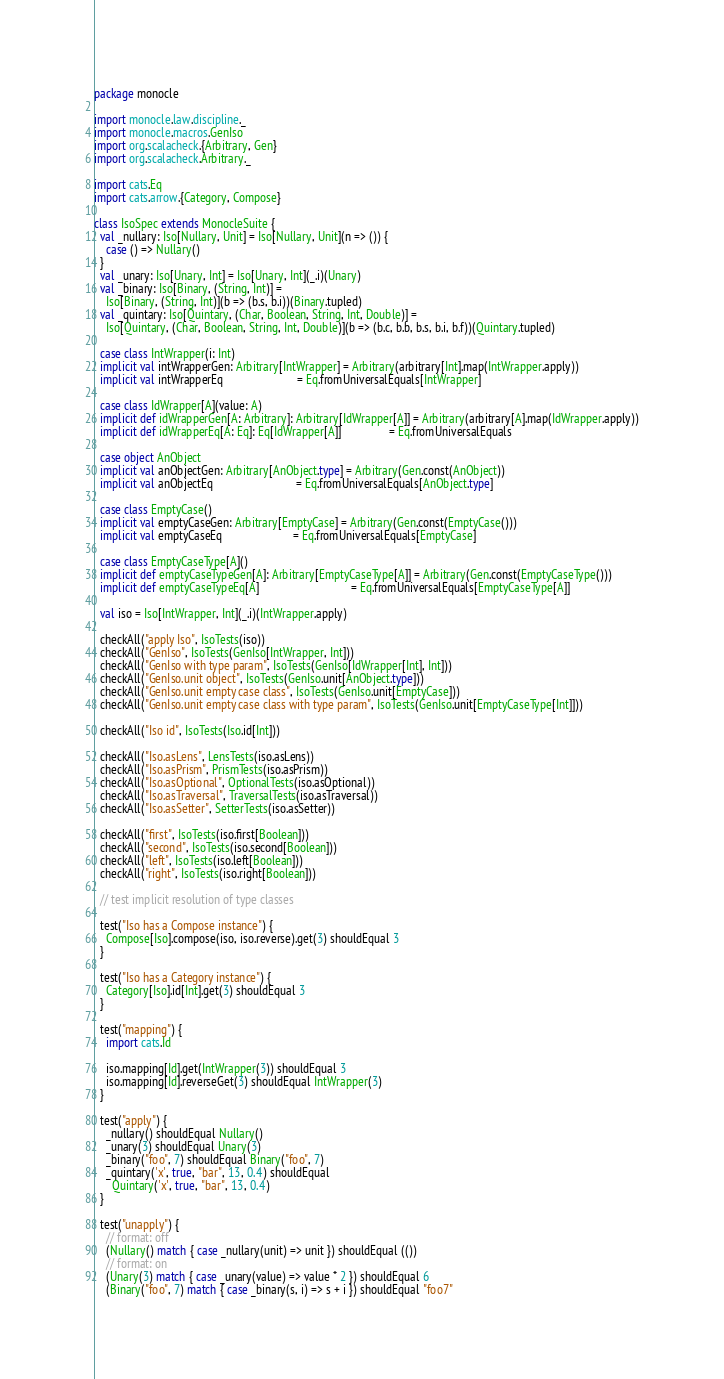Convert code to text. <code><loc_0><loc_0><loc_500><loc_500><_Scala_>package monocle

import monocle.law.discipline._
import monocle.macros.GenIso
import org.scalacheck.{Arbitrary, Gen}
import org.scalacheck.Arbitrary._

import cats.Eq
import cats.arrow.{Category, Compose}

class IsoSpec extends MonocleSuite {
  val _nullary: Iso[Nullary, Unit] = Iso[Nullary, Unit](n => ()) {
    case () => Nullary()
  }
  val _unary: Iso[Unary, Int] = Iso[Unary, Int](_.i)(Unary)
  val _binary: Iso[Binary, (String, Int)] =
    Iso[Binary, (String, Int)](b => (b.s, b.i))(Binary.tupled)
  val _quintary: Iso[Quintary, (Char, Boolean, String, Int, Double)] =
    Iso[Quintary, (Char, Boolean, String, Int, Double)](b => (b.c, b.b, b.s, b.i, b.f))(Quintary.tupled)

  case class IntWrapper(i: Int)
  implicit val intWrapperGen: Arbitrary[IntWrapper] = Arbitrary(arbitrary[Int].map(IntWrapper.apply))
  implicit val intWrapperEq                         = Eq.fromUniversalEquals[IntWrapper]

  case class IdWrapper[A](value: A)
  implicit def idWrapperGen[A: Arbitrary]: Arbitrary[IdWrapper[A]] = Arbitrary(arbitrary[A].map(IdWrapper.apply))
  implicit def idWrapperEq[A: Eq]: Eq[IdWrapper[A]]                = Eq.fromUniversalEquals

  case object AnObject
  implicit val anObjectGen: Arbitrary[AnObject.type] = Arbitrary(Gen.const(AnObject))
  implicit val anObjectEq                            = Eq.fromUniversalEquals[AnObject.type]

  case class EmptyCase()
  implicit val emptyCaseGen: Arbitrary[EmptyCase] = Arbitrary(Gen.const(EmptyCase()))
  implicit val emptyCaseEq                        = Eq.fromUniversalEquals[EmptyCase]

  case class EmptyCaseType[A]()
  implicit def emptyCaseTypeGen[A]: Arbitrary[EmptyCaseType[A]] = Arbitrary(Gen.const(EmptyCaseType()))
  implicit def emptyCaseTypeEq[A]                               = Eq.fromUniversalEquals[EmptyCaseType[A]]

  val iso = Iso[IntWrapper, Int](_.i)(IntWrapper.apply)

  checkAll("apply Iso", IsoTests(iso))
  checkAll("GenIso", IsoTests(GenIso[IntWrapper, Int]))
  checkAll("GenIso with type param", IsoTests(GenIso[IdWrapper[Int], Int]))
  checkAll("GenIso.unit object", IsoTests(GenIso.unit[AnObject.type]))
  checkAll("GenIso.unit empty case class", IsoTests(GenIso.unit[EmptyCase]))
  checkAll("GenIso.unit empty case class with type param", IsoTests(GenIso.unit[EmptyCaseType[Int]]))

  checkAll("Iso id", IsoTests(Iso.id[Int]))

  checkAll("Iso.asLens", LensTests(iso.asLens))
  checkAll("Iso.asPrism", PrismTests(iso.asPrism))
  checkAll("Iso.asOptional", OptionalTests(iso.asOptional))
  checkAll("Iso.asTraversal", TraversalTests(iso.asTraversal))
  checkAll("Iso.asSetter", SetterTests(iso.asSetter))

  checkAll("first", IsoTests(iso.first[Boolean]))
  checkAll("second", IsoTests(iso.second[Boolean]))
  checkAll("left", IsoTests(iso.left[Boolean]))
  checkAll("right", IsoTests(iso.right[Boolean]))

  // test implicit resolution of type classes

  test("Iso has a Compose instance") {
    Compose[Iso].compose(iso, iso.reverse).get(3) shouldEqual 3
  }

  test("Iso has a Category instance") {
    Category[Iso].id[Int].get(3) shouldEqual 3
  }

  test("mapping") {
    import cats.Id

    iso.mapping[Id].get(IntWrapper(3)) shouldEqual 3
    iso.mapping[Id].reverseGet(3) shouldEqual IntWrapper(3)
  }

  test("apply") {
    _nullary() shouldEqual Nullary()
    _unary(3) shouldEqual Unary(3)
    _binary("foo", 7) shouldEqual Binary("foo", 7)
    _quintary('x', true, "bar", 13, 0.4) shouldEqual
      Quintary('x', true, "bar", 13, 0.4)
  }

  test("unapply") {
    // format: off
    (Nullary() match { case _nullary(unit) => unit }) shouldEqual (())
    // format: on
    (Unary(3) match { case _unary(value) => value * 2 }) shouldEqual 6
    (Binary("foo", 7) match { case _binary(s, i) => s + i }) shouldEqual "foo7"</code> 